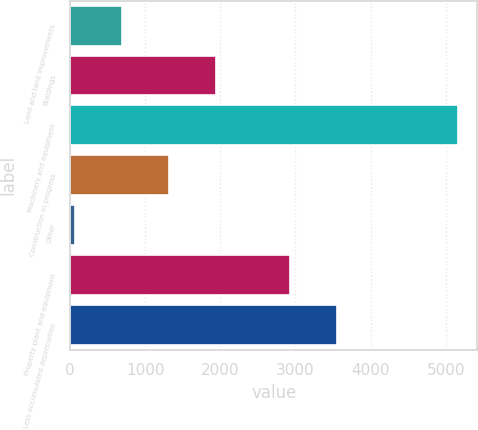Convert chart. <chart><loc_0><loc_0><loc_500><loc_500><bar_chart><fcel>Land and land improvements<fcel>Buildings<fcel>Machinery and equipment<fcel>Construction in progress<fcel>Other<fcel>Property plant and equipment<fcel>Less accumulated depreciation<nl><fcel>692.68<fcel>1941.24<fcel>5162.5<fcel>1316.96<fcel>68.4<fcel>2924.9<fcel>3549.18<nl></chart> 